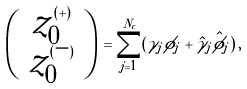Convert formula to latex. <formula><loc_0><loc_0><loc_500><loc_500>\left ( \begin{array} { c } z ^ { ( + ) } _ { 0 } \\ z ^ { ( - ) } _ { 0 } \end{array} \right ) \, = \sum _ { j = 1 } ^ { N _ { c } } ( \gamma _ { j } \phi _ { j } + \hat { \gamma } _ { j } \hat { \phi } _ { j } ) \, ,</formula> 